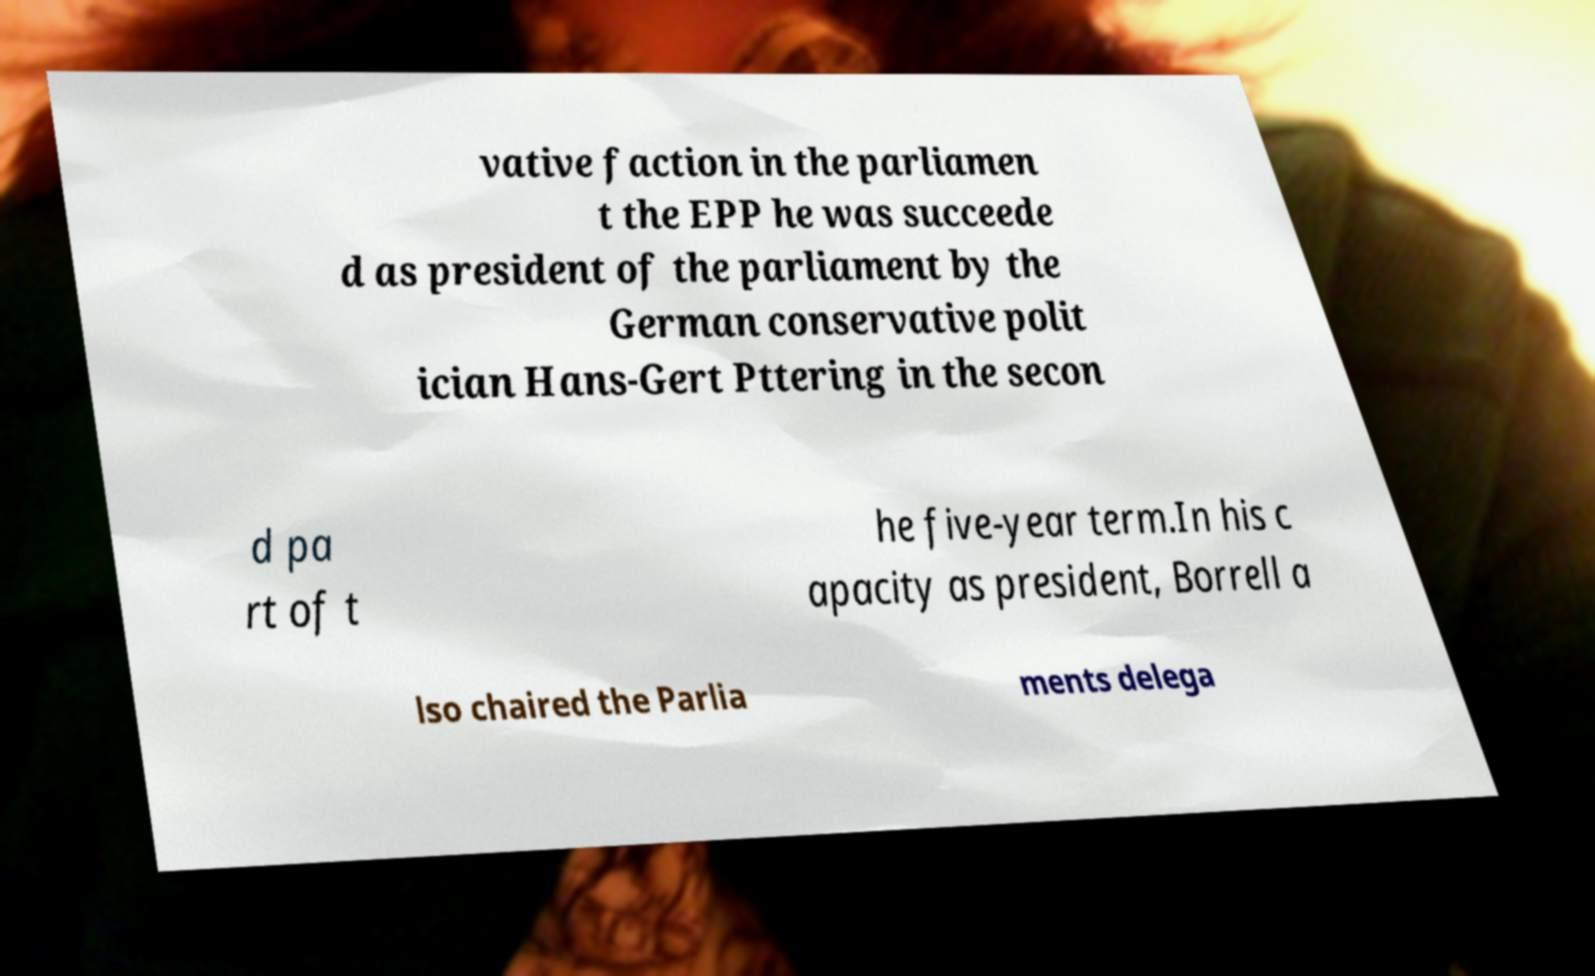I need the written content from this picture converted into text. Can you do that? vative faction in the parliamen t the EPP he was succeede d as president of the parliament by the German conservative polit ician Hans-Gert Pttering in the secon d pa rt of t he five-year term.In his c apacity as president, Borrell a lso chaired the Parlia ments delega 